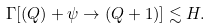Convert formula to latex. <formula><loc_0><loc_0><loc_500><loc_500>\Gamma [ ( Q ) + \psi \to ( Q + 1 ) ] \lesssim H .</formula> 